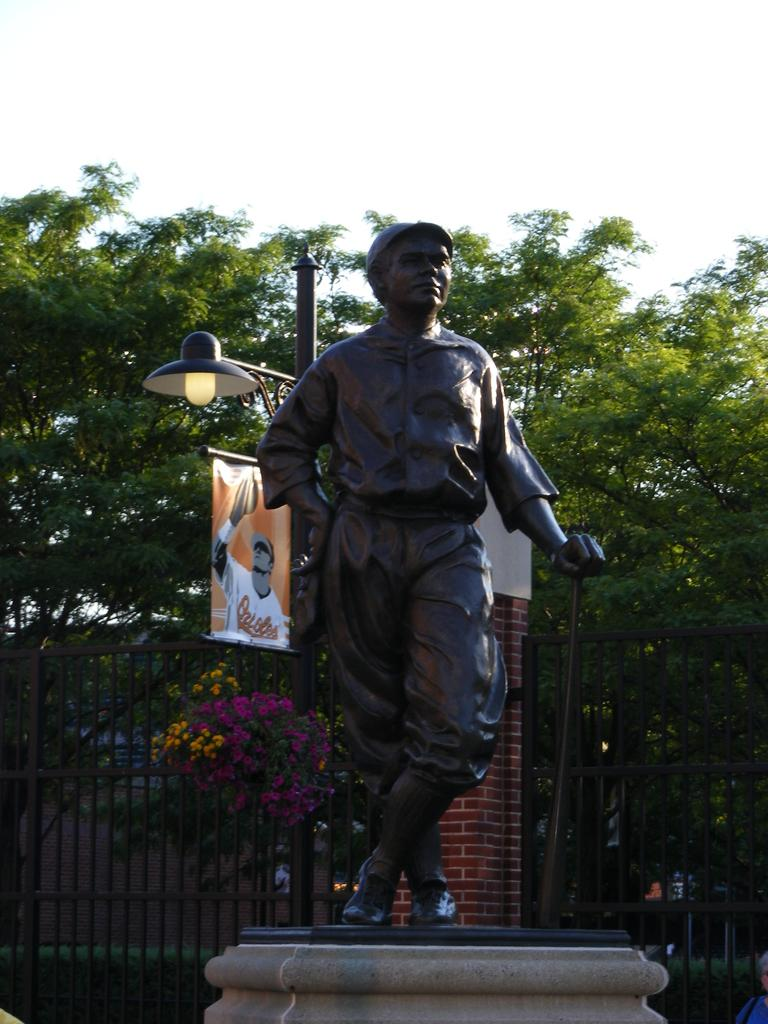What is the main subject in the image? There is a statue in the image. What is the statue standing on? The statue is standing on a pedestal in the image. What other objects can be seen in the image? There is a street pole, a street light, an advertisement, flowers near a plant, trees, grills, and the sky is visible in the image. What type of leather is covering the earth in the image? There is no leather or earth present in the image. The image features a statue, pedestal, street pole, street light, advertisement, flowers, trees, grills, and the sky. 